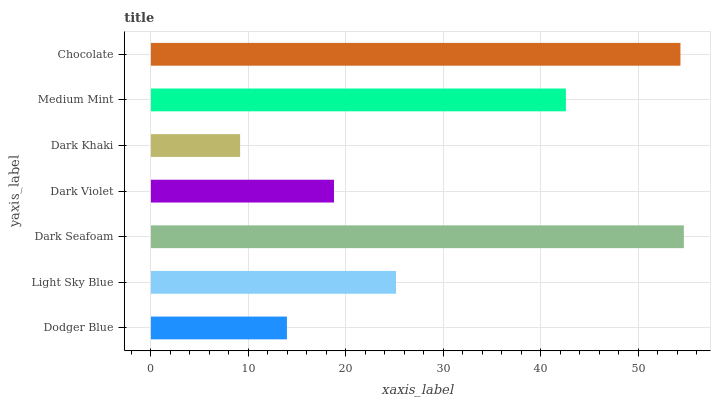Is Dark Khaki the minimum?
Answer yes or no. Yes. Is Dark Seafoam the maximum?
Answer yes or no. Yes. Is Light Sky Blue the minimum?
Answer yes or no. No. Is Light Sky Blue the maximum?
Answer yes or no. No. Is Light Sky Blue greater than Dodger Blue?
Answer yes or no. Yes. Is Dodger Blue less than Light Sky Blue?
Answer yes or no. Yes. Is Dodger Blue greater than Light Sky Blue?
Answer yes or no. No. Is Light Sky Blue less than Dodger Blue?
Answer yes or no. No. Is Light Sky Blue the high median?
Answer yes or no. Yes. Is Light Sky Blue the low median?
Answer yes or no. Yes. Is Chocolate the high median?
Answer yes or no. No. Is Dodger Blue the low median?
Answer yes or no. No. 